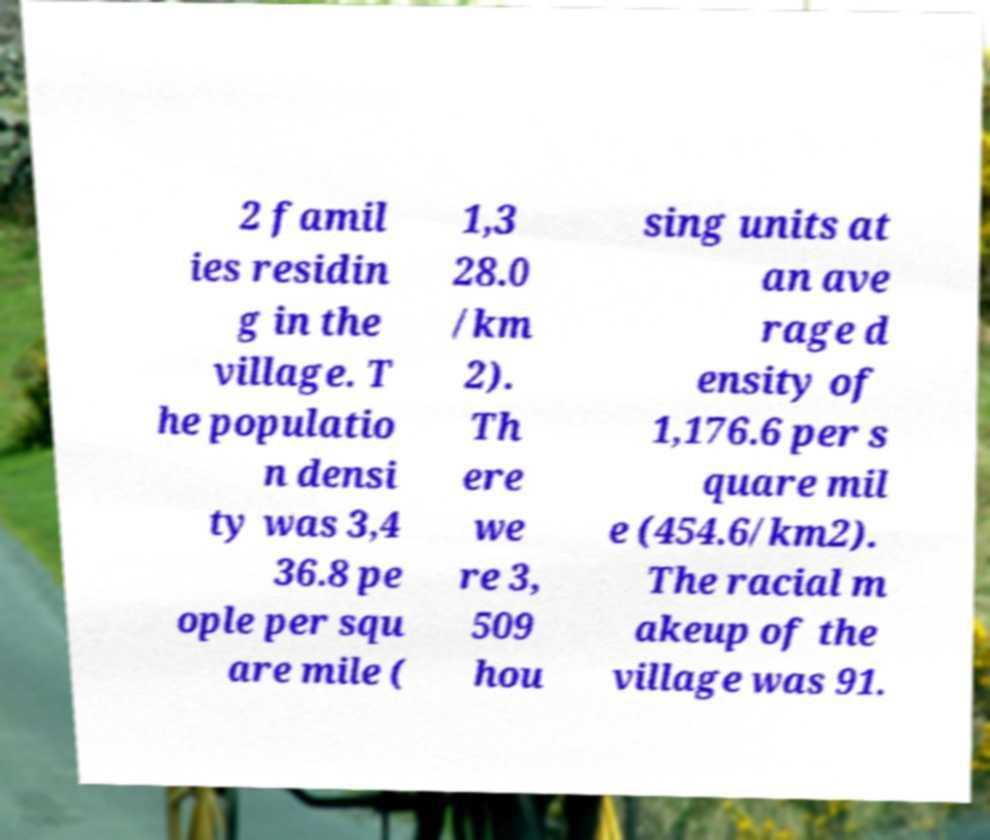Could you extract and type out the text from this image? 2 famil ies residin g in the village. T he populatio n densi ty was 3,4 36.8 pe ople per squ are mile ( 1,3 28.0 /km 2). Th ere we re 3, 509 hou sing units at an ave rage d ensity of 1,176.6 per s quare mil e (454.6/km2). The racial m akeup of the village was 91. 